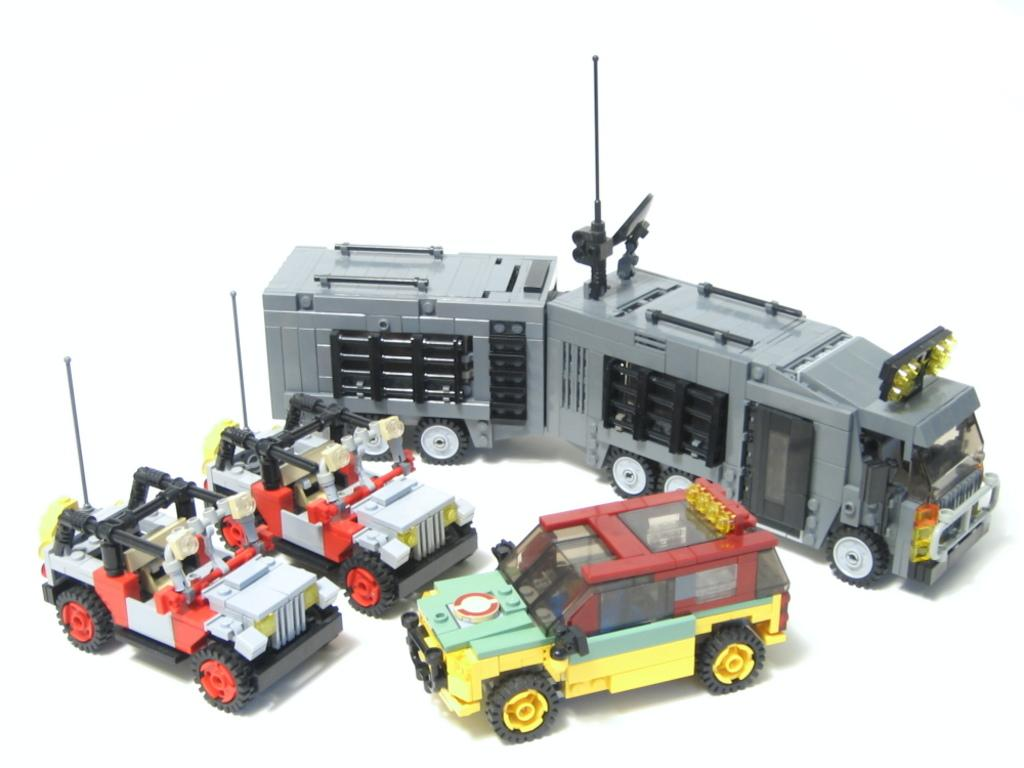What type of objects are present in the image? There are toy vehicles in the image. What is the color of the surface on which the toy vehicles are placed? The toy vehicles are on a white surface. Can you tell me how many cannons are present on the street in the image? There are no cannons or streets present in the image; it features toy vehicles on a white surface. 